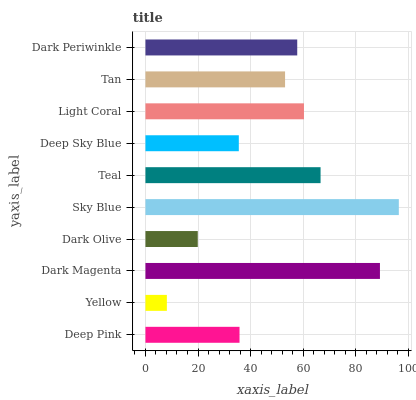Is Yellow the minimum?
Answer yes or no. Yes. Is Sky Blue the maximum?
Answer yes or no. Yes. Is Dark Magenta the minimum?
Answer yes or no. No. Is Dark Magenta the maximum?
Answer yes or no. No. Is Dark Magenta greater than Yellow?
Answer yes or no. Yes. Is Yellow less than Dark Magenta?
Answer yes or no. Yes. Is Yellow greater than Dark Magenta?
Answer yes or no. No. Is Dark Magenta less than Yellow?
Answer yes or no. No. Is Dark Periwinkle the high median?
Answer yes or no. Yes. Is Tan the low median?
Answer yes or no. Yes. Is Dark Magenta the high median?
Answer yes or no. No. Is Sky Blue the low median?
Answer yes or no. No. 